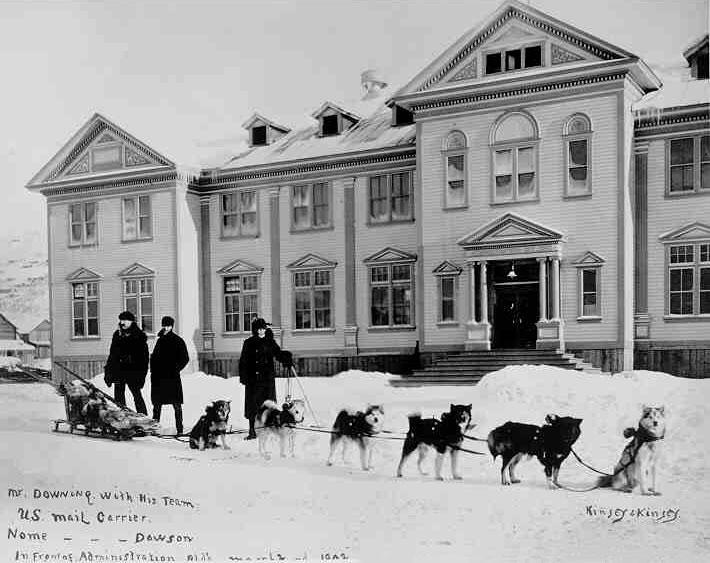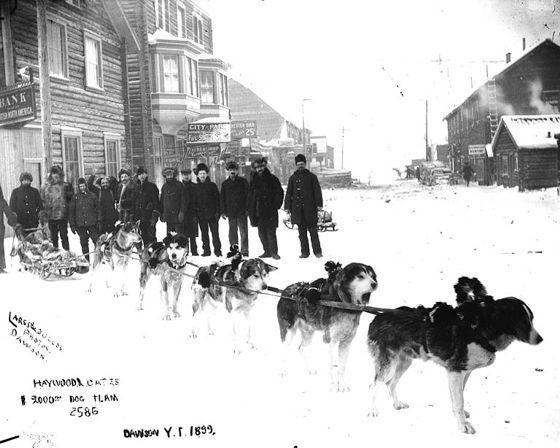The first image is the image on the left, the second image is the image on the right. Given the left and right images, does the statement "A pack of dogs is standing in the snow near a building in the image on the left." hold true? Answer yes or no. Yes. The first image is the image on the left, the second image is the image on the right. Evaluate the accuracy of this statement regarding the images: "One image shows a team of rope-hitched dogs resting on the snow, with no sled or any landmarks in sight and with at least some dogs reclining.". Is it true? Answer yes or no. No. 